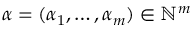Convert formula to latex. <formula><loc_0><loc_0><loc_500><loc_500>\alpha = ( \alpha _ { 1 } , \dots , \alpha _ { m } ) \in { \mathbb { N } } ^ { m }</formula> 